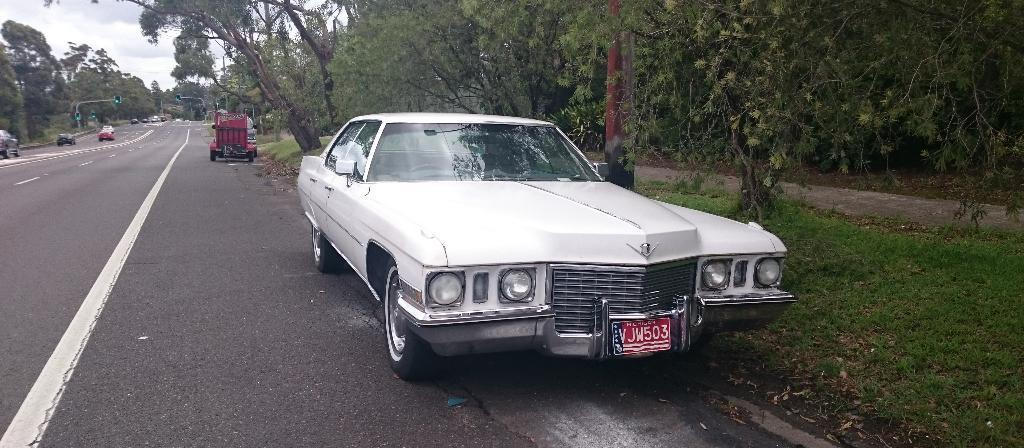What can be seen on the road in the image? There are vehicles on the road in the image. What type of natural environment is visible in the background of the image? There are trees and grass in the background of the image. What type of traffic control device is present in the background of the image? There are traffic lights in the background of the image. What is visible in the sky in the image? The sky is visible in the background of the image. What type of markings are on the road in the image? There are white lines on the road in the image. Where is the coal mine located in the image? There is no coal mine present in the image. What type of reading material can be seen in the hands of the crowd in the image? There is no crowd or reading material present in the image. 